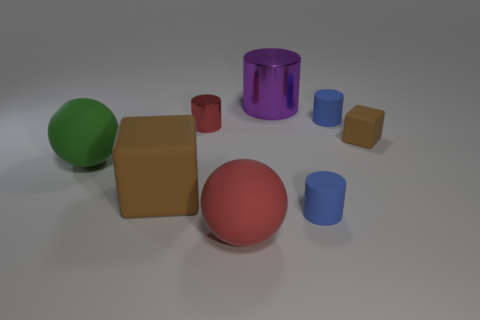There is a tiny block; is its color the same as the rubber block that is left of the big red matte thing?
Offer a terse response. Yes. There is a brown cube to the right of the blue rubber thing that is behind the matte sphere that is on the left side of the red metallic cylinder; what is its material?
Make the answer very short. Rubber. The metallic thing in front of the large purple cylinder has what shape?
Your answer should be compact. Cylinder. What size is the other ball that is made of the same material as the big red sphere?
Give a very brief answer. Large. How many other things have the same shape as the tiny red metallic object?
Offer a very short reply. 3. Is the color of the ball that is in front of the big green thing the same as the small metal thing?
Give a very brief answer. Yes. There is a brown rubber thing right of the big metallic cylinder that is on the right side of the big green rubber ball; how many tiny objects are in front of it?
Provide a succinct answer. 1. What number of cylinders are both in front of the tiny red thing and on the left side of the big purple object?
Keep it short and to the point. 0. What shape is the rubber object that is the same color as the big rubber cube?
Make the answer very short. Cube. Does the red ball have the same material as the tiny red thing?
Make the answer very short. No. 